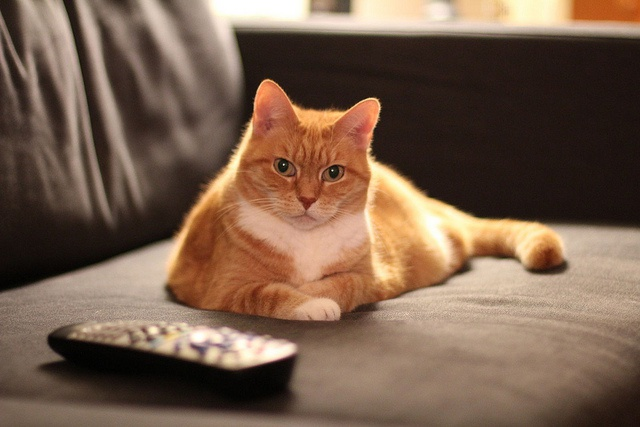Describe the objects in this image and their specific colors. I can see couch in black, gray, and tan tones, cat in black, brown, tan, salmon, and khaki tones, and remote in black, ivory, and tan tones in this image. 